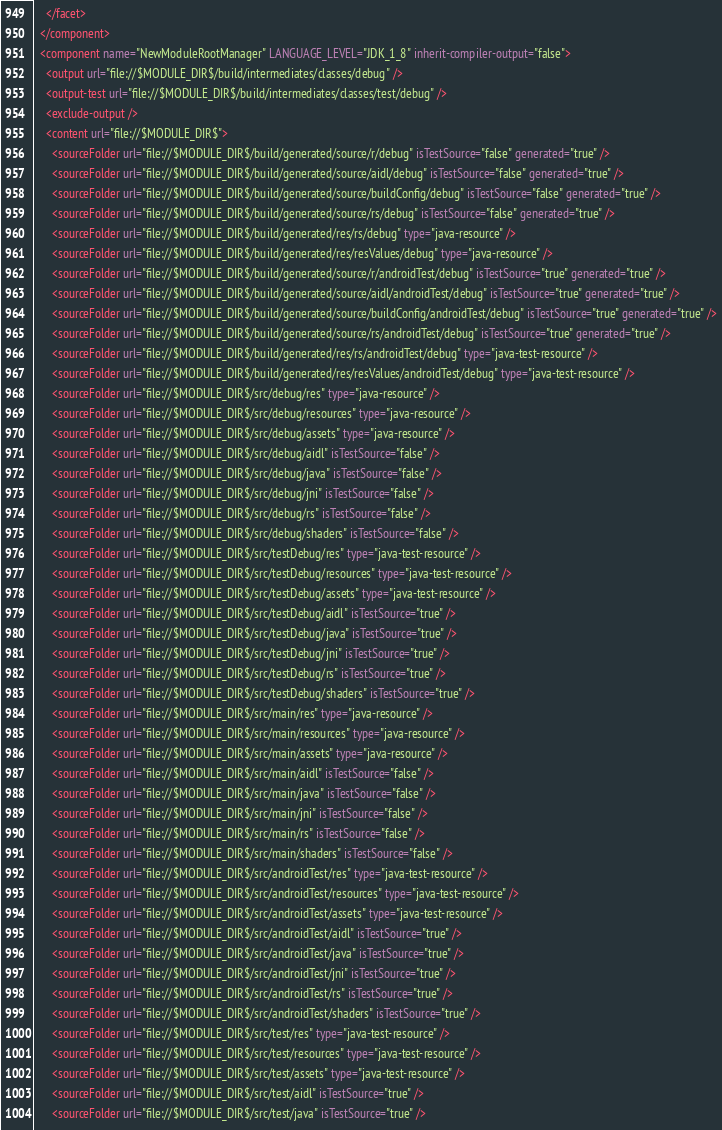<code> <loc_0><loc_0><loc_500><loc_500><_XML_>    </facet>
  </component>
  <component name="NewModuleRootManager" LANGUAGE_LEVEL="JDK_1_8" inherit-compiler-output="false">
    <output url="file://$MODULE_DIR$/build/intermediates/classes/debug" />
    <output-test url="file://$MODULE_DIR$/build/intermediates/classes/test/debug" />
    <exclude-output />
    <content url="file://$MODULE_DIR$">
      <sourceFolder url="file://$MODULE_DIR$/build/generated/source/r/debug" isTestSource="false" generated="true" />
      <sourceFolder url="file://$MODULE_DIR$/build/generated/source/aidl/debug" isTestSource="false" generated="true" />
      <sourceFolder url="file://$MODULE_DIR$/build/generated/source/buildConfig/debug" isTestSource="false" generated="true" />
      <sourceFolder url="file://$MODULE_DIR$/build/generated/source/rs/debug" isTestSource="false" generated="true" />
      <sourceFolder url="file://$MODULE_DIR$/build/generated/res/rs/debug" type="java-resource" />
      <sourceFolder url="file://$MODULE_DIR$/build/generated/res/resValues/debug" type="java-resource" />
      <sourceFolder url="file://$MODULE_DIR$/build/generated/source/r/androidTest/debug" isTestSource="true" generated="true" />
      <sourceFolder url="file://$MODULE_DIR$/build/generated/source/aidl/androidTest/debug" isTestSource="true" generated="true" />
      <sourceFolder url="file://$MODULE_DIR$/build/generated/source/buildConfig/androidTest/debug" isTestSource="true" generated="true" />
      <sourceFolder url="file://$MODULE_DIR$/build/generated/source/rs/androidTest/debug" isTestSource="true" generated="true" />
      <sourceFolder url="file://$MODULE_DIR$/build/generated/res/rs/androidTest/debug" type="java-test-resource" />
      <sourceFolder url="file://$MODULE_DIR$/build/generated/res/resValues/androidTest/debug" type="java-test-resource" />
      <sourceFolder url="file://$MODULE_DIR$/src/debug/res" type="java-resource" />
      <sourceFolder url="file://$MODULE_DIR$/src/debug/resources" type="java-resource" />
      <sourceFolder url="file://$MODULE_DIR$/src/debug/assets" type="java-resource" />
      <sourceFolder url="file://$MODULE_DIR$/src/debug/aidl" isTestSource="false" />
      <sourceFolder url="file://$MODULE_DIR$/src/debug/java" isTestSource="false" />
      <sourceFolder url="file://$MODULE_DIR$/src/debug/jni" isTestSource="false" />
      <sourceFolder url="file://$MODULE_DIR$/src/debug/rs" isTestSource="false" />
      <sourceFolder url="file://$MODULE_DIR$/src/debug/shaders" isTestSource="false" />
      <sourceFolder url="file://$MODULE_DIR$/src/testDebug/res" type="java-test-resource" />
      <sourceFolder url="file://$MODULE_DIR$/src/testDebug/resources" type="java-test-resource" />
      <sourceFolder url="file://$MODULE_DIR$/src/testDebug/assets" type="java-test-resource" />
      <sourceFolder url="file://$MODULE_DIR$/src/testDebug/aidl" isTestSource="true" />
      <sourceFolder url="file://$MODULE_DIR$/src/testDebug/java" isTestSource="true" />
      <sourceFolder url="file://$MODULE_DIR$/src/testDebug/jni" isTestSource="true" />
      <sourceFolder url="file://$MODULE_DIR$/src/testDebug/rs" isTestSource="true" />
      <sourceFolder url="file://$MODULE_DIR$/src/testDebug/shaders" isTestSource="true" />
      <sourceFolder url="file://$MODULE_DIR$/src/main/res" type="java-resource" />
      <sourceFolder url="file://$MODULE_DIR$/src/main/resources" type="java-resource" />
      <sourceFolder url="file://$MODULE_DIR$/src/main/assets" type="java-resource" />
      <sourceFolder url="file://$MODULE_DIR$/src/main/aidl" isTestSource="false" />
      <sourceFolder url="file://$MODULE_DIR$/src/main/java" isTestSource="false" />
      <sourceFolder url="file://$MODULE_DIR$/src/main/jni" isTestSource="false" />
      <sourceFolder url="file://$MODULE_DIR$/src/main/rs" isTestSource="false" />
      <sourceFolder url="file://$MODULE_DIR$/src/main/shaders" isTestSource="false" />
      <sourceFolder url="file://$MODULE_DIR$/src/androidTest/res" type="java-test-resource" />
      <sourceFolder url="file://$MODULE_DIR$/src/androidTest/resources" type="java-test-resource" />
      <sourceFolder url="file://$MODULE_DIR$/src/androidTest/assets" type="java-test-resource" />
      <sourceFolder url="file://$MODULE_DIR$/src/androidTest/aidl" isTestSource="true" />
      <sourceFolder url="file://$MODULE_DIR$/src/androidTest/java" isTestSource="true" />
      <sourceFolder url="file://$MODULE_DIR$/src/androidTest/jni" isTestSource="true" />
      <sourceFolder url="file://$MODULE_DIR$/src/androidTest/rs" isTestSource="true" />
      <sourceFolder url="file://$MODULE_DIR$/src/androidTest/shaders" isTestSource="true" />
      <sourceFolder url="file://$MODULE_DIR$/src/test/res" type="java-test-resource" />
      <sourceFolder url="file://$MODULE_DIR$/src/test/resources" type="java-test-resource" />
      <sourceFolder url="file://$MODULE_DIR$/src/test/assets" type="java-test-resource" />
      <sourceFolder url="file://$MODULE_DIR$/src/test/aidl" isTestSource="true" />
      <sourceFolder url="file://$MODULE_DIR$/src/test/java" isTestSource="true" /></code> 